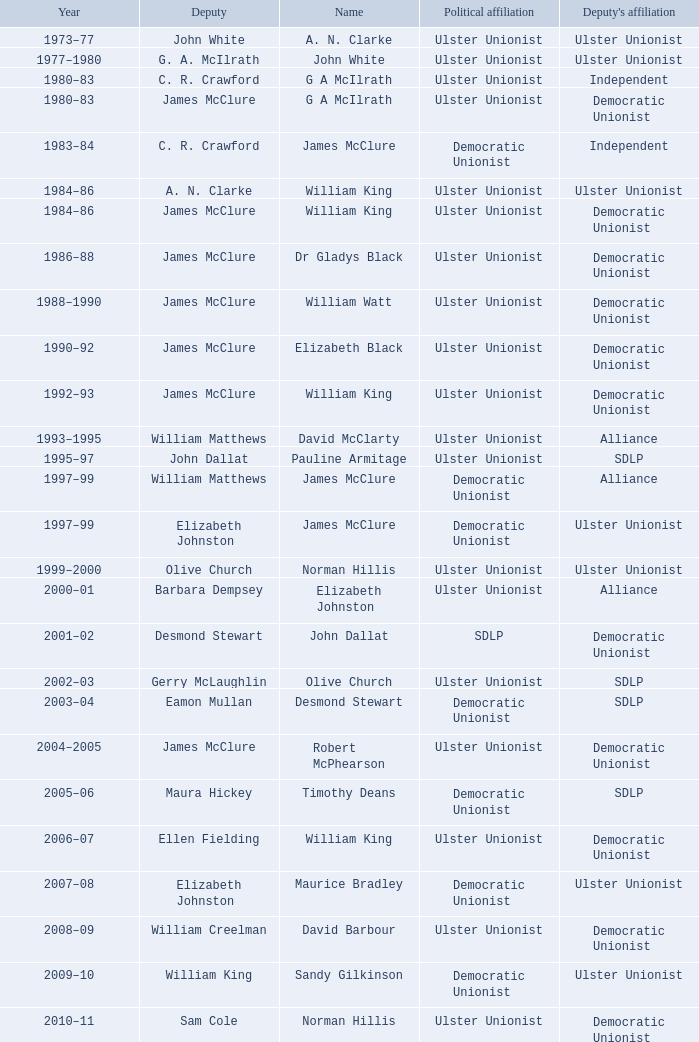In which year did james mcclure serve as deputy, and is the individual named robert mcphearson? 2004–2005. 